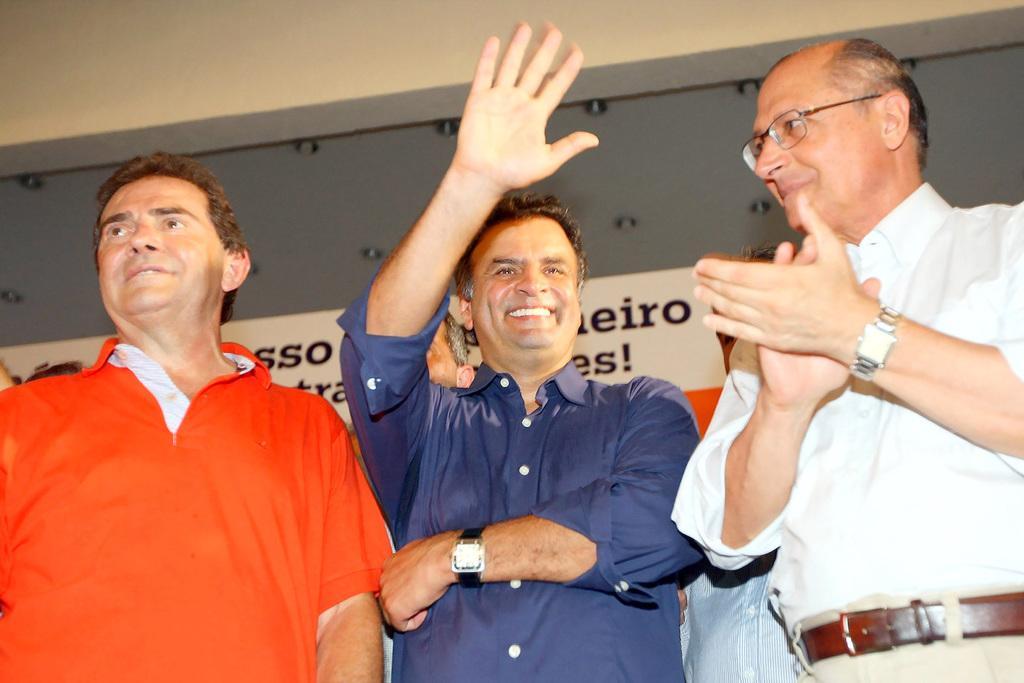Describe this image in one or two sentences. In front of the image there are three people standing with a smile on their face, one of them is waving and the other one is clapping, behind them there are a few other people, in the background of the image there is a banner on the wall, at the top of the wall there are lamps. 